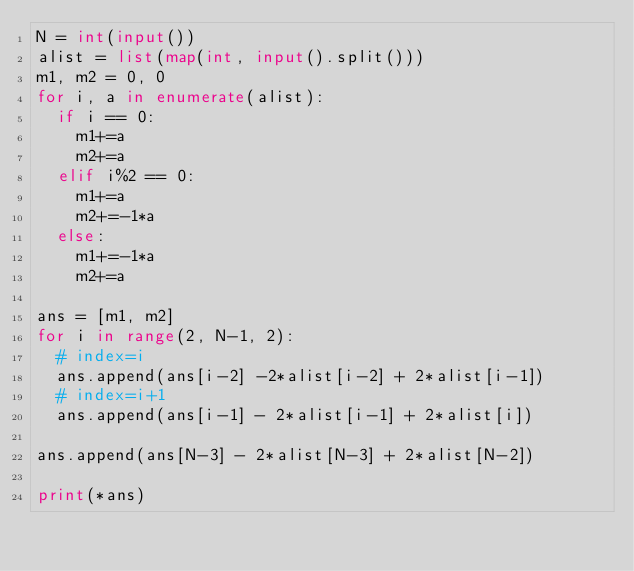<code> <loc_0><loc_0><loc_500><loc_500><_Python_>N = int(input())
alist = list(map(int, input().split()))
m1, m2 = 0, 0
for i, a in enumerate(alist):
  if i == 0:
    m1+=a
    m2+=a
  elif i%2 == 0:
    m1+=a
    m2+=-1*a
  else:
    m1+=-1*a
    m2+=a    

ans = [m1, m2]
for i in range(2, N-1, 2):
  # index=i
  ans.append(ans[i-2] -2*alist[i-2] + 2*alist[i-1])
  # index=i+1
  ans.append(ans[i-1] - 2*alist[i-1] + 2*alist[i])

ans.append(ans[N-3] - 2*alist[N-3] + 2*alist[N-2])

print(*ans)</code> 